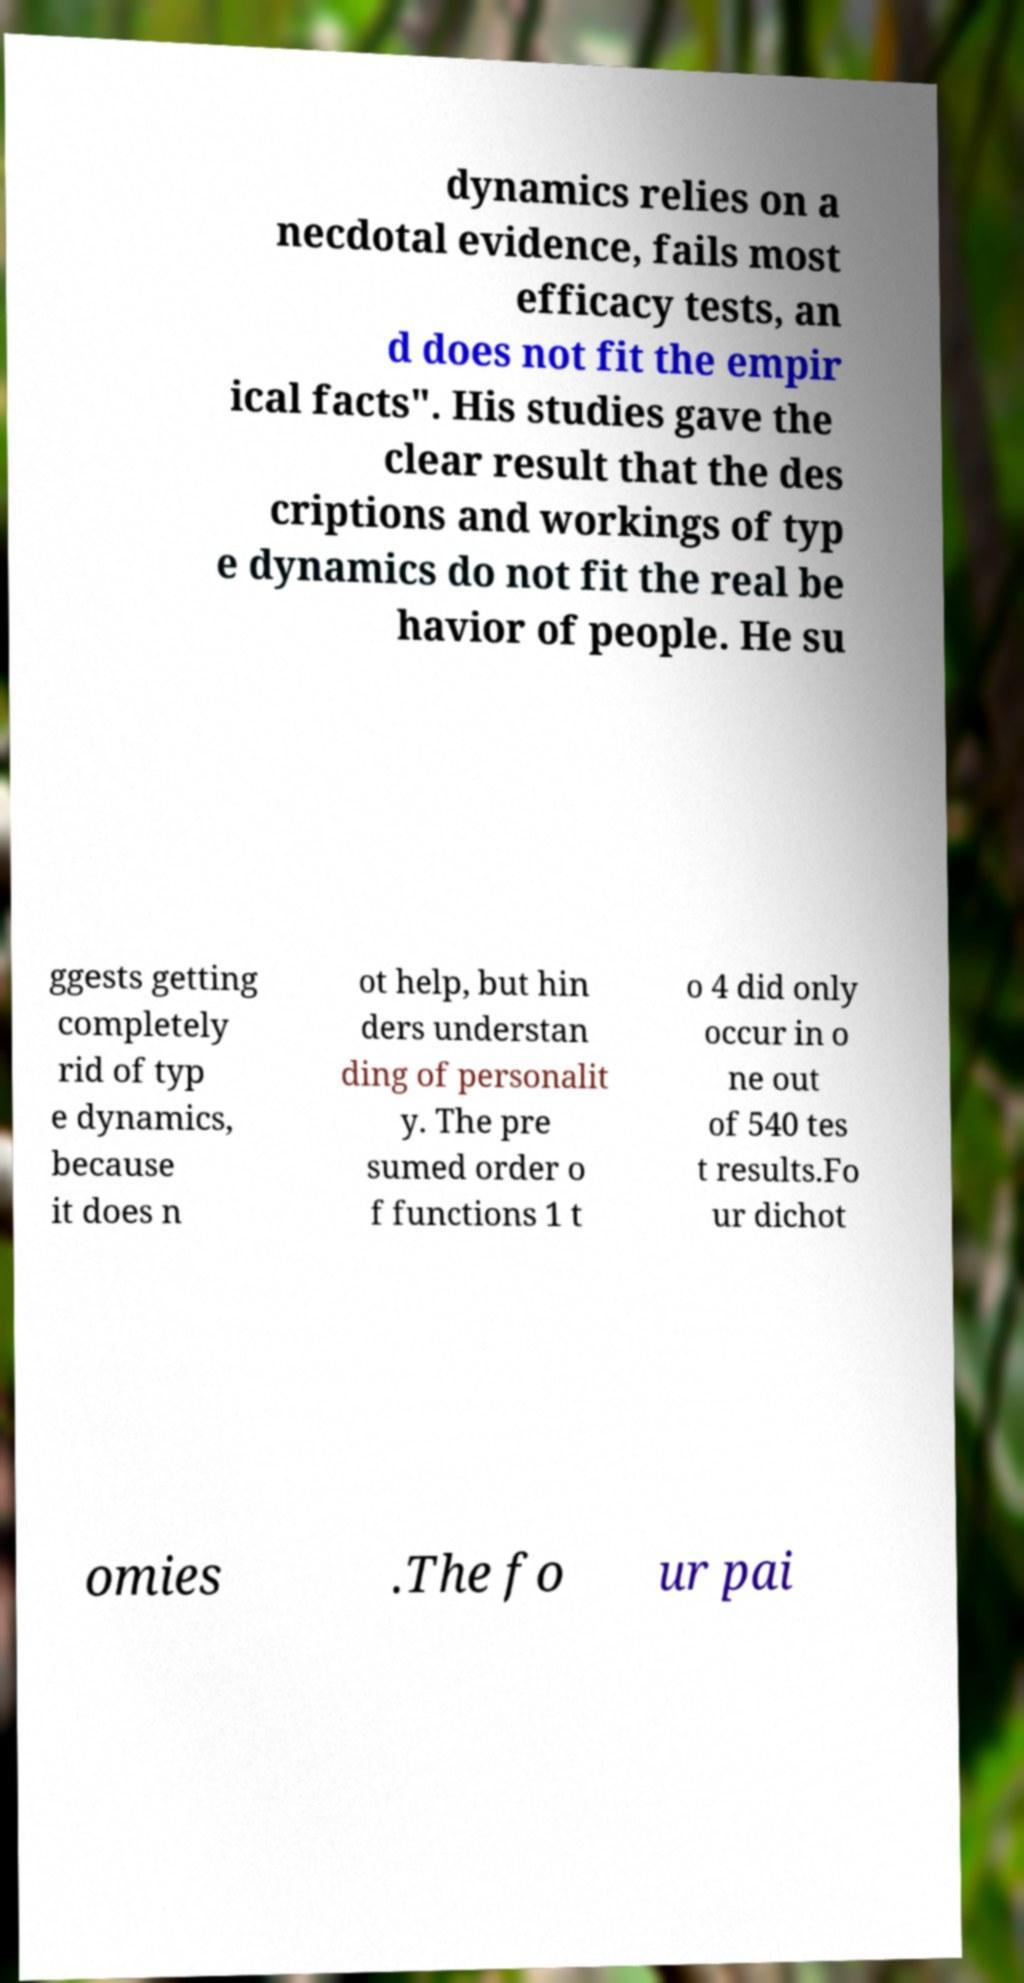There's text embedded in this image that I need extracted. Can you transcribe it verbatim? dynamics relies on a necdotal evidence, fails most efficacy tests, an d does not fit the empir ical facts". His studies gave the clear result that the des criptions and workings of typ e dynamics do not fit the real be havior of people. He su ggests getting completely rid of typ e dynamics, because it does n ot help, but hin ders understan ding of personalit y. The pre sumed order o f functions 1 t o 4 did only occur in o ne out of 540 tes t results.Fo ur dichot omies .The fo ur pai 